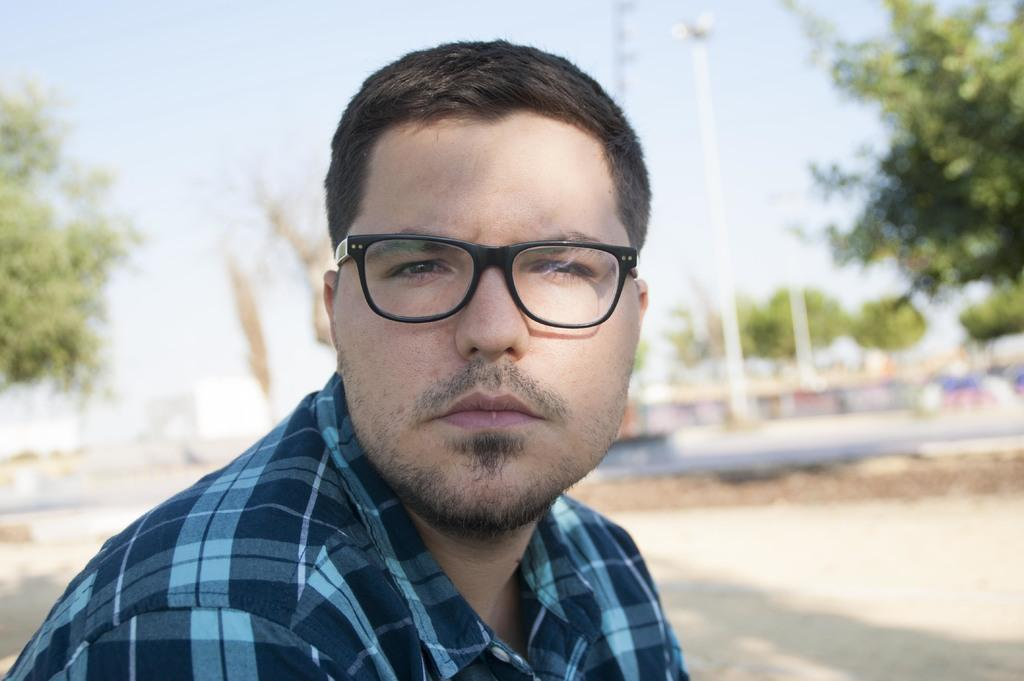Who is present in the image? There is a man in the image. What is the man wearing on his upper body? The man is wearing a shirt. What accessory is the man wearing on his face? The man is wearing glasses. Can you describe the background of the image? The background of the image is blurry, but trees, poles, the ground, and the sky are visible. What type of nerve is visible in the image? There is no nerve visible in the image; it features a man wearing a shirt and glasses, with a blurry background containing trees, poles, the ground, and the sky. 